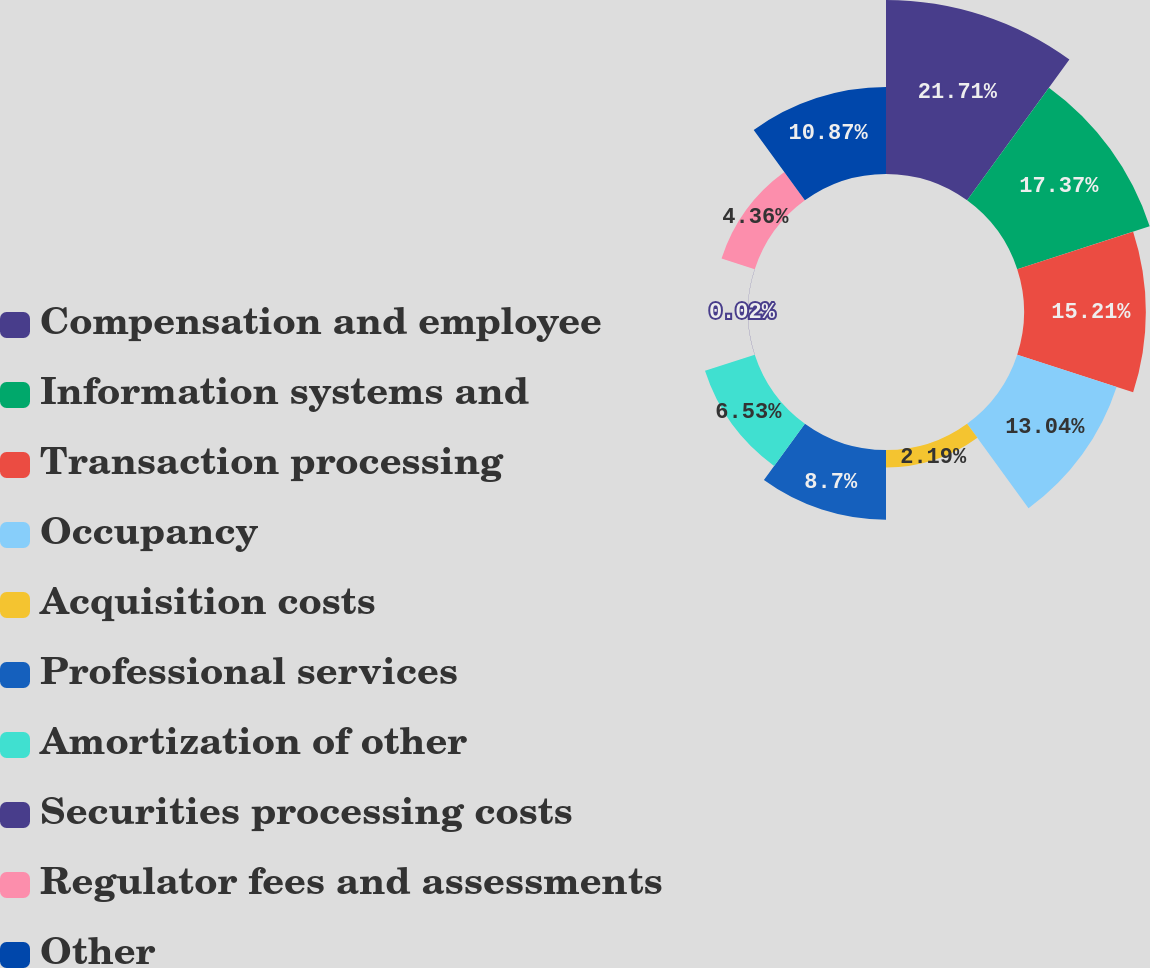Convert chart to OTSL. <chart><loc_0><loc_0><loc_500><loc_500><pie_chart><fcel>Compensation and employee<fcel>Information systems and<fcel>Transaction processing<fcel>Occupancy<fcel>Acquisition costs<fcel>Professional services<fcel>Amortization of other<fcel>Securities processing costs<fcel>Regulator fees and assessments<fcel>Other<nl><fcel>21.72%<fcel>17.38%<fcel>15.21%<fcel>13.04%<fcel>2.19%<fcel>8.7%<fcel>6.53%<fcel>0.02%<fcel>4.36%<fcel>10.87%<nl></chart> 